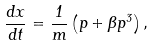<formula> <loc_0><loc_0><loc_500><loc_500>\frac { d x } { d t } = \frac { 1 } { m } \left ( p + \beta p ^ { 3 } \right ) ,</formula> 